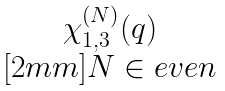<formula> <loc_0><loc_0><loc_500><loc_500>\begin{matrix} \chi _ { 1 , 3 } ^ { ( N ) } ( q ) \\ [ 2 m m ] N \in e v e n \end{matrix}</formula> 